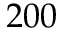<formula> <loc_0><loc_0><loc_500><loc_500>2 0 0</formula> 